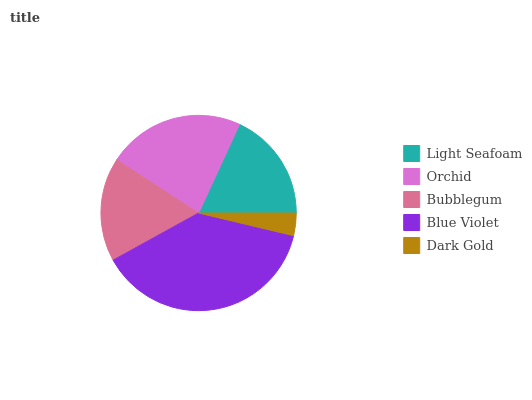Is Dark Gold the minimum?
Answer yes or no. Yes. Is Blue Violet the maximum?
Answer yes or no. Yes. Is Orchid the minimum?
Answer yes or no. No. Is Orchid the maximum?
Answer yes or no. No. Is Orchid greater than Light Seafoam?
Answer yes or no. Yes. Is Light Seafoam less than Orchid?
Answer yes or no. Yes. Is Light Seafoam greater than Orchid?
Answer yes or no. No. Is Orchid less than Light Seafoam?
Answer yes or no. No. Is Light Seafoam the high median?
Answer yes or no. Yes. Is Light Seafoam the low median?
Answer yes or no. Yes. Is Dark Gold the high median?
Answer yes or no. No. Is Dark Gold the low median?
Answer yes or no. No. 